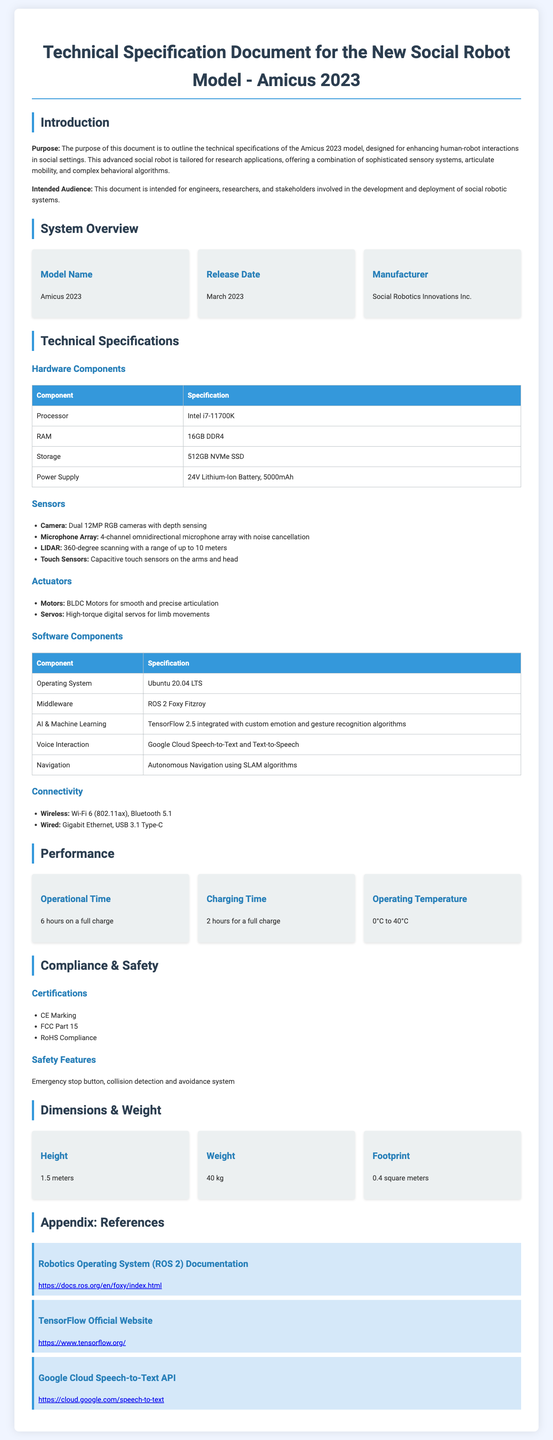What is the model name? The model name is identified in the system overview section as the Amicus 2023.
Answer: Amicus 2023 What is the release date? The release date is clearly stated in the system overview section as March 2023.
Answer: March 2023 What type of operating system does the robot use? The operating system is mentioned in the software components section, specifically as Ubuntu 20.04 LTS.
Answer: Ubuntu 20.04 LTS How many MP do the cameras have? The specification of the camera in the sensors section includes that they have dual 12MP RGB cameras.
Answer: 12MP What is the operational time on a full charge? This information is provided in the performance section, which states the operational time is 6 hours on a full charge.
Answer: 6 hours What type of battery is used for power supply? The power supply section describes a 24V Lithium-Ion Battery, which provides specifics about the type of battery.
Answer: 24V Lithium-Ion Battery What are the dimensions of the robot? The dimensions are given in the dimensions & weight section. The height is 1.5 meters, and the weight is 40 kg.
Answer: 1.5 meters, 40 kg What safety features does the robot include? The safety features are outlined in the Compliance & Safety section, mentioning an emergency stop button and a collision detection and avoidance system.
Answer: Emergency stop button, collision detection and avoidance system Which middleware is used? The middleware used by the robot, noted in the software components section, is ROS 2 Foxy Fitzroy.
Answer: ROS 2 Foxy Fitzroy 